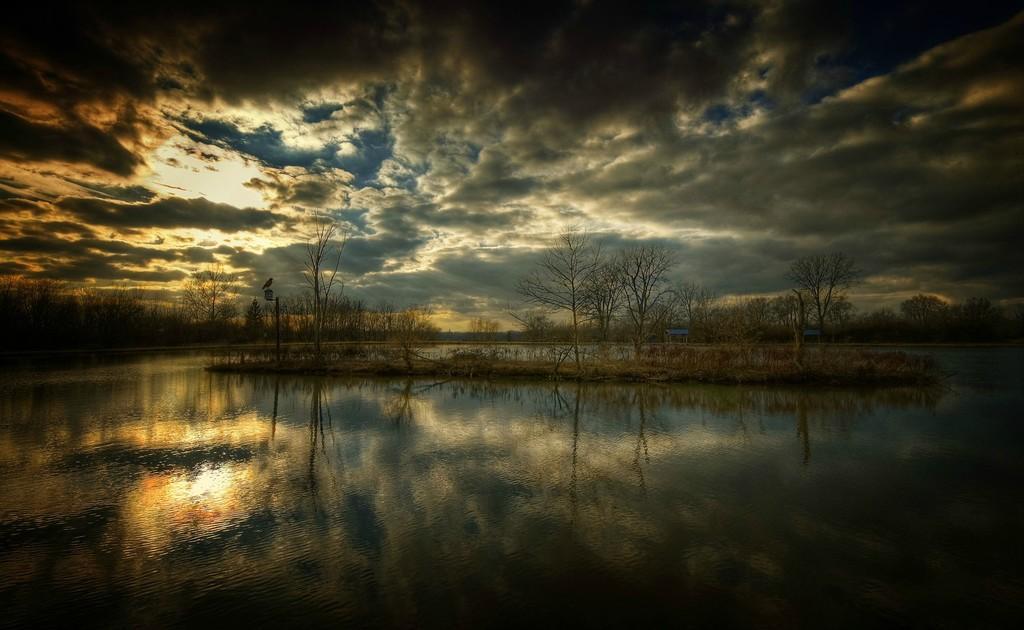Please provide a concise description of this image. In this picture there is water at the bottom side of the image and there are trees in the center of the image and there is a bird on the pole in the image and there is sky at the top side of the image. 